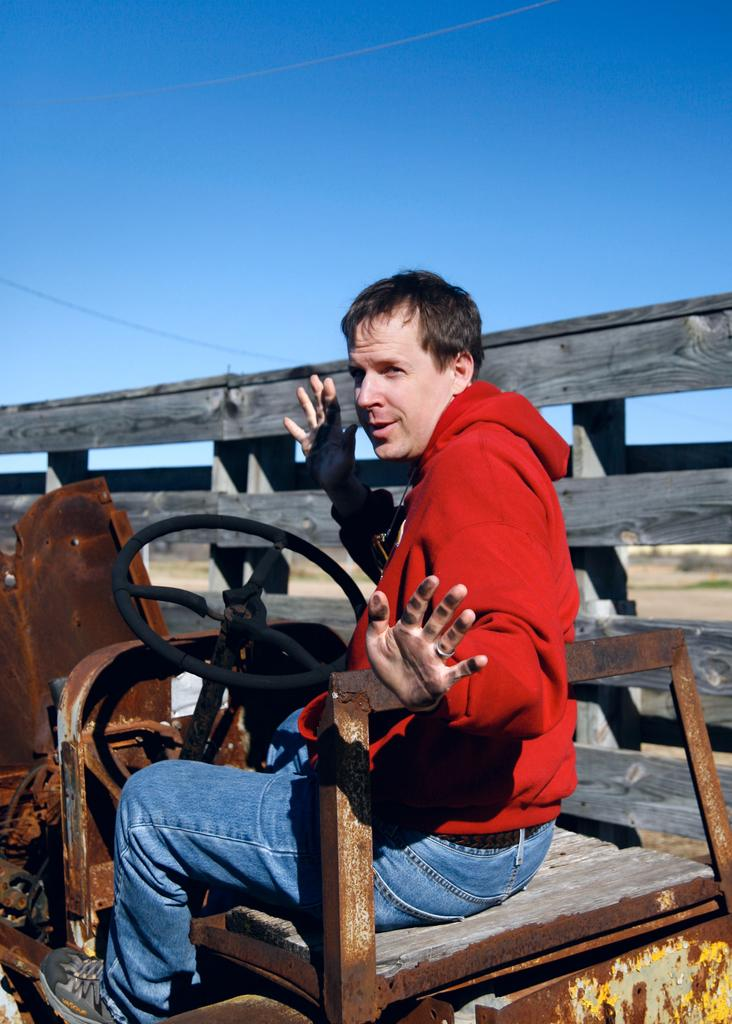What is the person in the image doing? There is a person sitting on a vehicle in the image. What can be seen near the vehicle in the image? There is a fence in the image. What is visible in the background of the image? Trees, the ground, and the sky are visible in the background of the image. What type of brick is being used to build the toy in the image? There is no brick or toy present in the image. 